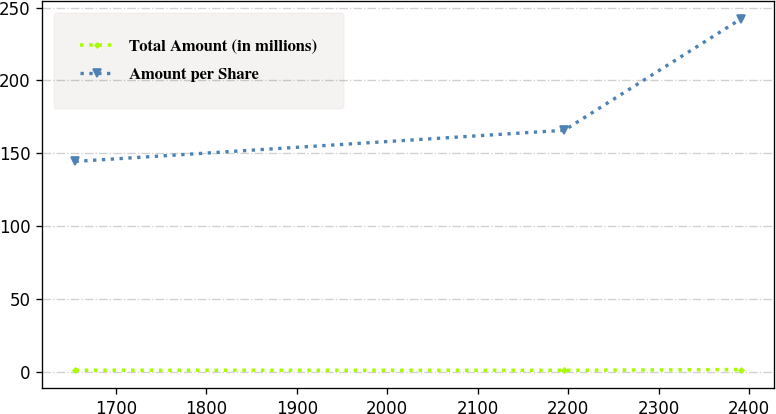<chart> <loc_0><loc_0><loc_500><loc_500><line_chart><ecel><fcel>Total Amount (in millions)<fcel>Amount per Share<nl><fcel>1655.23<fcel>1.03<fcel>144.42<nl><fcel>2195.69<fcel>0.98<fcel>165.8<nl><fcel>2391.24<fcel>1.49<fcel>242.34<nl></chart> 